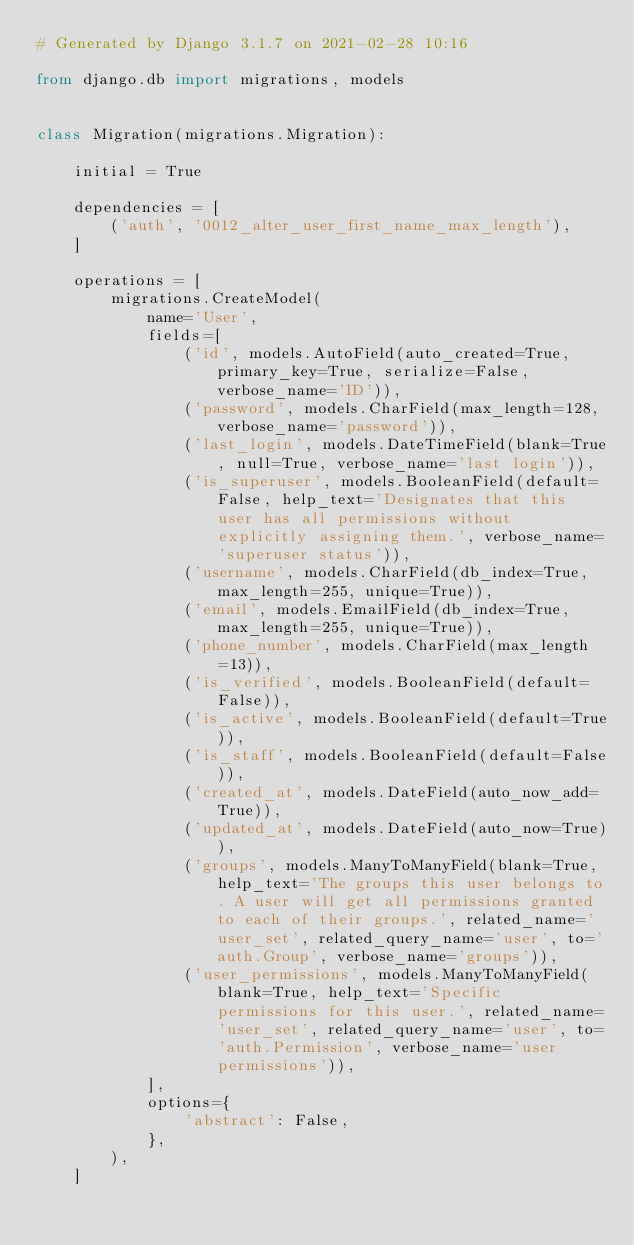Convert code to text. <code><loc_0><loc_0><loc_500><loc_500><_Python_># Generated by Django 3.1.7 on 2021-02-28 10:16

from django.db import migrations, models


class Migration(migrations.Migration):

    initial = True

    dependencies = [
        ('auth', '0012_alter_user_first_name_max_length'),
    ]

    operations = [
        migrations.CreateModel(
            name='User',
            fields=[
                ('id', models.AutoField(auto_created=True, primary_key=True, serialize=False, verbose_name='ID')),
                ('password', models.CharField(max_length=128, verbose_name='password')),
                ('last_login', models.DateTimeField(blank=True, null=True, verbose_name='last login')),
                ('is_superuser', models.BooleanField(default=False, help_text='Designates that this user has all permissions without explicitly assigning them.', verbose_name='superuser status')),
                ('username', models.CharField(db_index=True, max_length=255, unique=True)),
                ('email', models.EmailField(db_index=True, max_length=255, unique=True)),
                ('phone_number', models.CharField(max_length=13)),
                ('is_verified', models.BooleanField(default=False)),
                ('is_active', models.BooleanField(default=True)),
                ('is_staff', models.BooleanField(default=False)),
                ('created_at', models.DateField(auto_now_add=True)),
                ('updated_at', models.DateField(auto_now=True)),
                ('groups', models.ManyToManyField(blank=True, help_text='The groups this user belongs to. A user will get all permissions granted to each of their groups.', related_name='user_set', related_query_name='user', to='auth.Group', verbose_name='groups')),
                ('user_permissions', models.ManyToManyField(blank=True, help_text='Specific permissions for this user.', related_name='user_set', related_query_name='user', to='auth.Permission', verbose_name='user permissions')),
            ],
            options={
                'abstract': False,
            },
        ),
    ]
</code> 